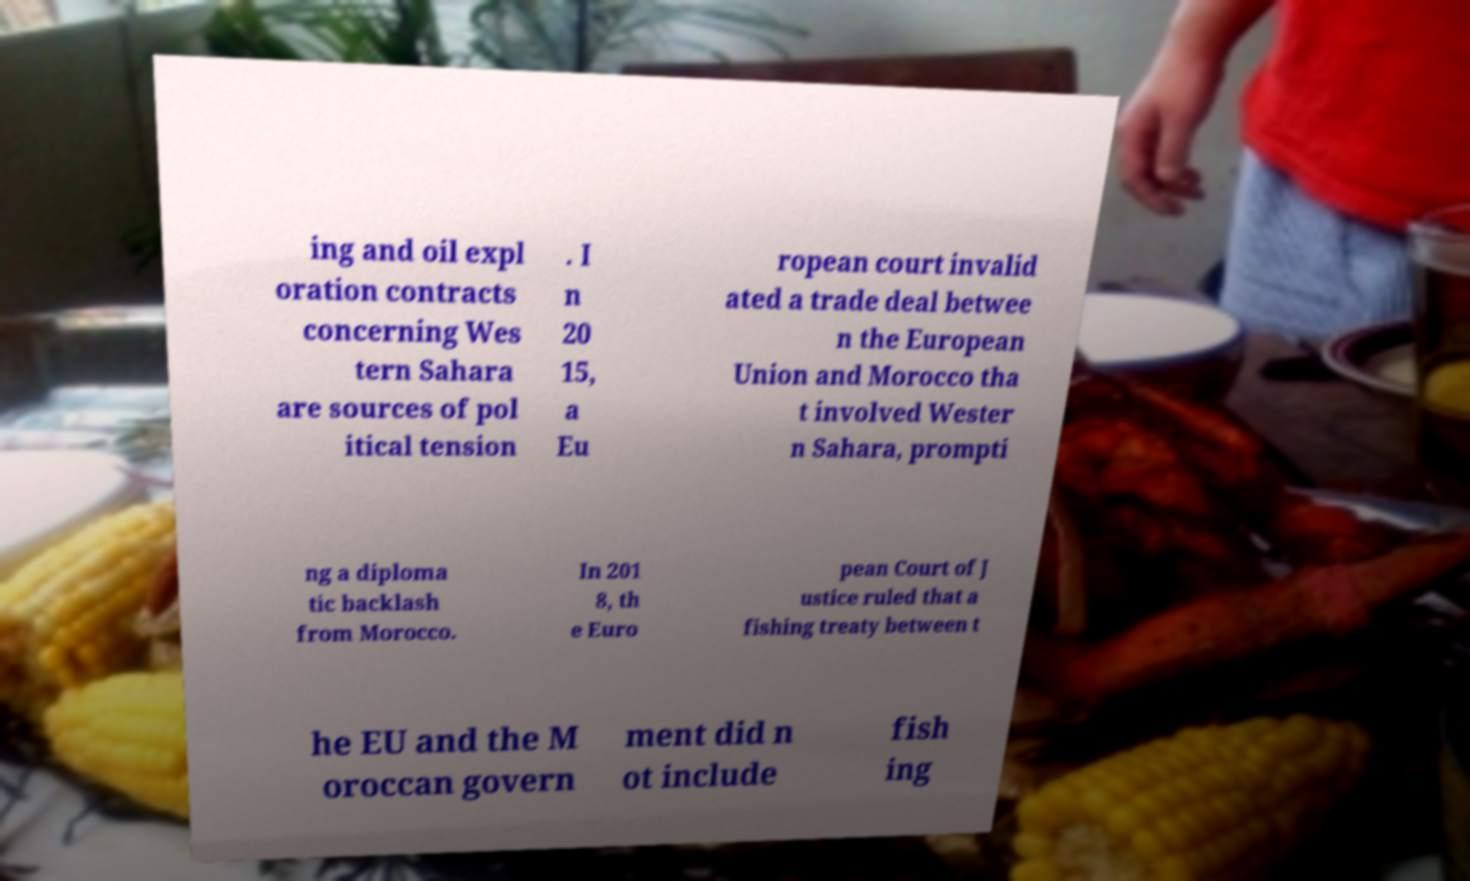Please identify and transcribe the text found in this image. ing and oil expl oration contracts concerning Wes tern Sahara are sources of pol itical tension . I n 20 15, a Eu ropean court invalid ated a trade deal betwee n the European Union and Morocco tha t involved Wester n Sahara, prompti ng a diploma tic backlash from Morocco. In 201 8, th e Euro pean Court of J ustice ruled that a fishing treaty between t he EU and the M oroccan govern ment did n ot include fish ing 